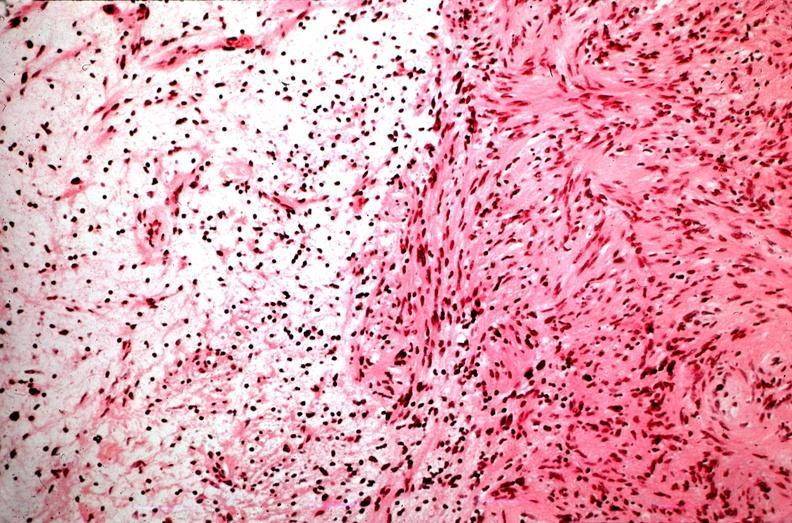s esophagus present?
Answer the question using a single word or phrase. No 